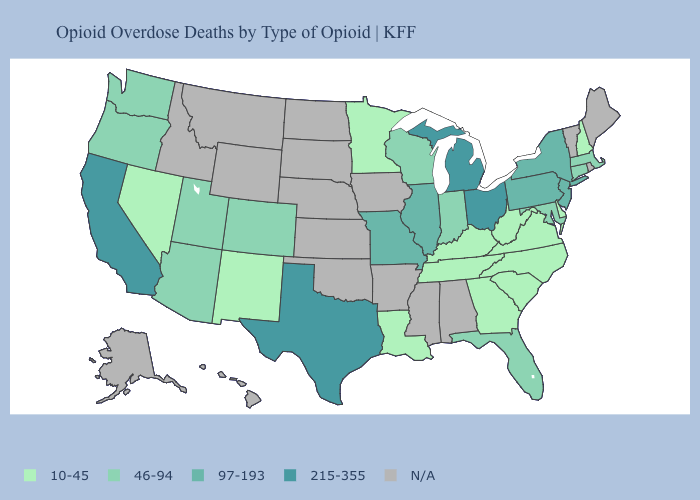How many symbols are there in the legend?
Quick response, please. 5. Name the states that have a value in the range 46-94?
Concise answer only. Arizona, Colorado, Connecticut, Florida, Indiana, Maryland, Massachusetts, Oregon, Utah, Washington, Wisconsin. What is the value of Wyoming?
Write a very short answer. N/A. Does Louisiana have the lowest value in the USA?
Keep it brief. Yes. Name the states that have a value in the range N/A?
Give a very brief answer. Alabama, Alaska, Arkansas, Hawaii, Idaho, Iowa, Kansas, Maine, Mississippi, Montana, Nebraska, North Dakota, Oklahoma, Rhode Island, South Dakota, Vermont, Wyoming. Which states hav the highest value in the South?
Write a very short answer. Texas. Does Virginia have the lowest value in the USA?
Answer briefly. Yes. Which states hav the highest value in the Northeast?
Give a very brief answer. New Jersey, New York, Pennsylvania. Name the states that have a value in the range N/A?
Concise answer only. Alabama, Alaska, Arkansas, Hawaii, Idaho, Iowa, Kansas, Maine, Mississippi, Montana, Nebraska, North Dakota, Oklahoma, Rhode Island, South Dakota, Vermont, Wyoming. Which states have the highest value in the USA?
Keep it brief. California, Michigan, Ohio, Texas. Does the first symbol in the legend represent the smallest category?
Keep it brief. Yes. 